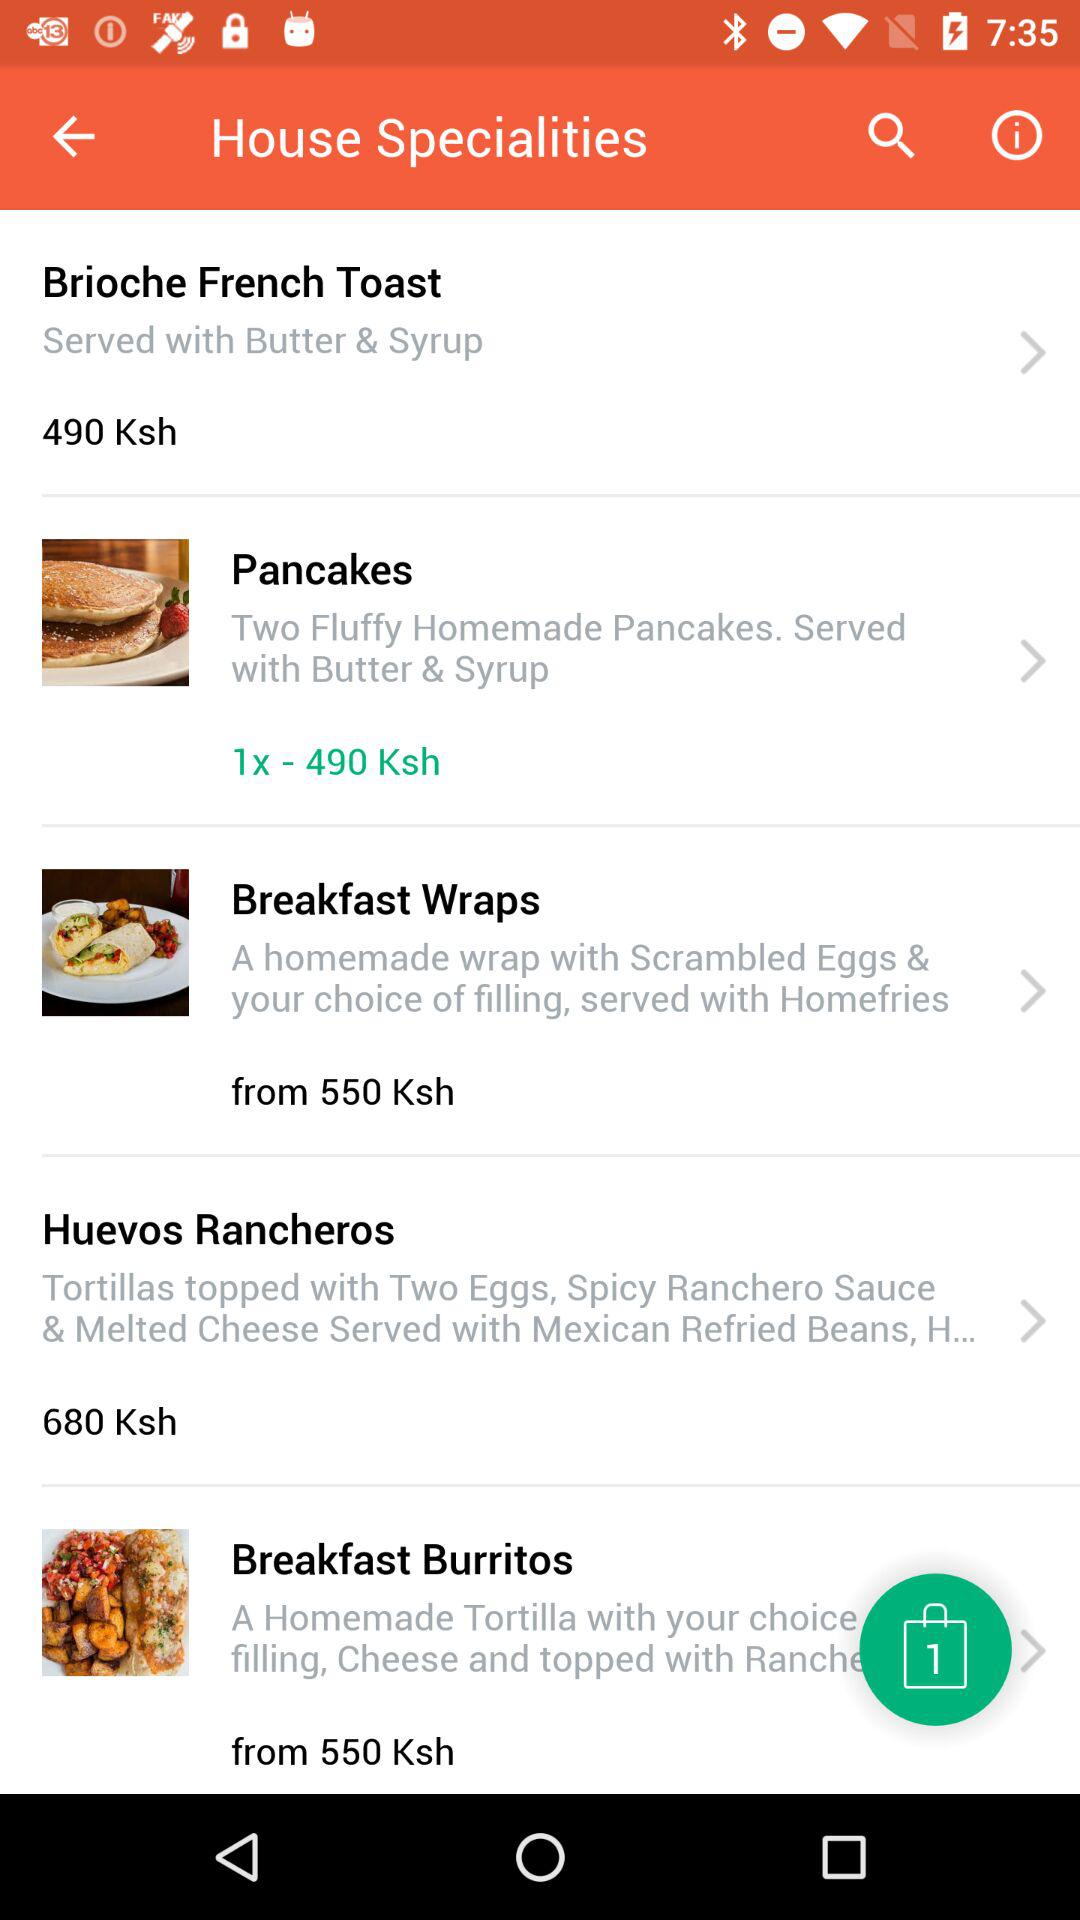How much is the most expensive breakfast item?
Answer the question using a single word or phrase. 680 Ksh 